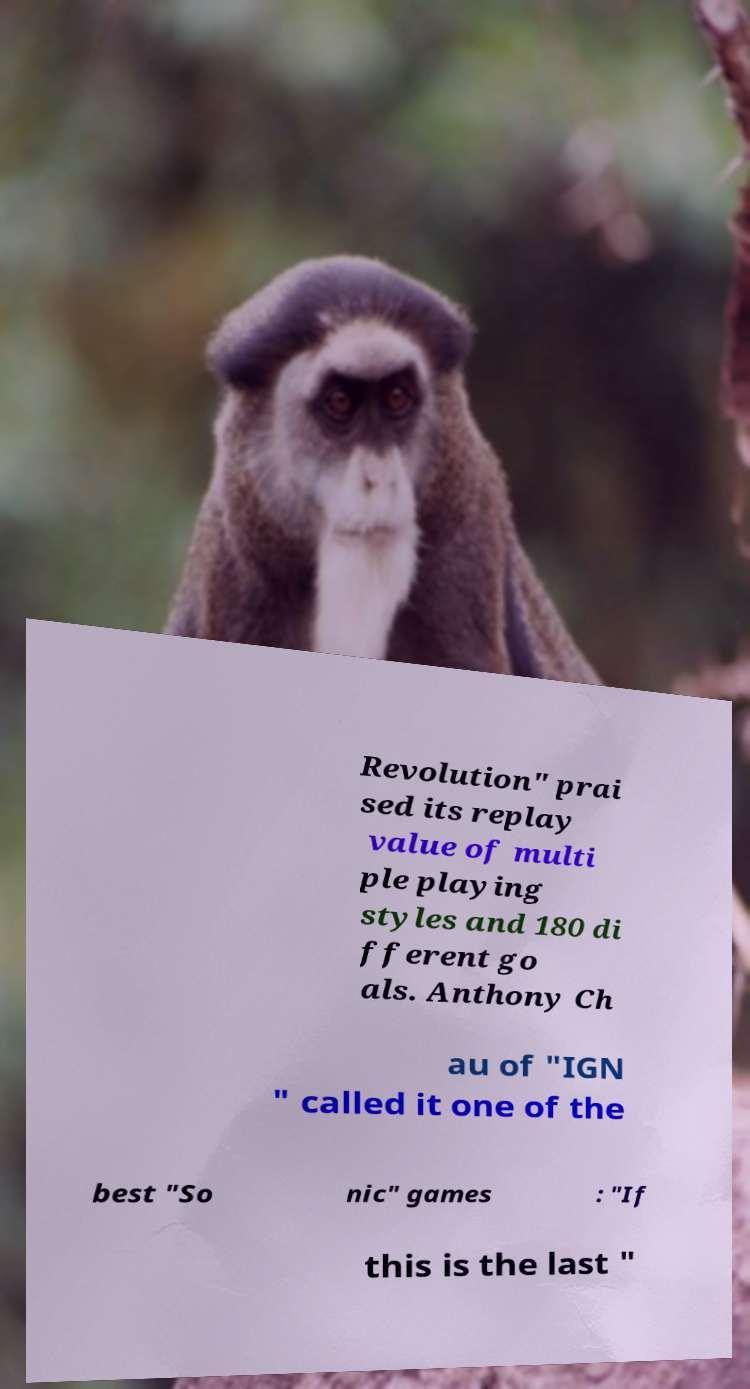For documentation purposes, I need the text within this image transcribed. Could you provide that? Revolution" prai sed its replay value of multi ple playing styles and 180 di fferent go als. Anthony Ch au of "IGN " called it one of the best "So nic" games : "If this is the last " 